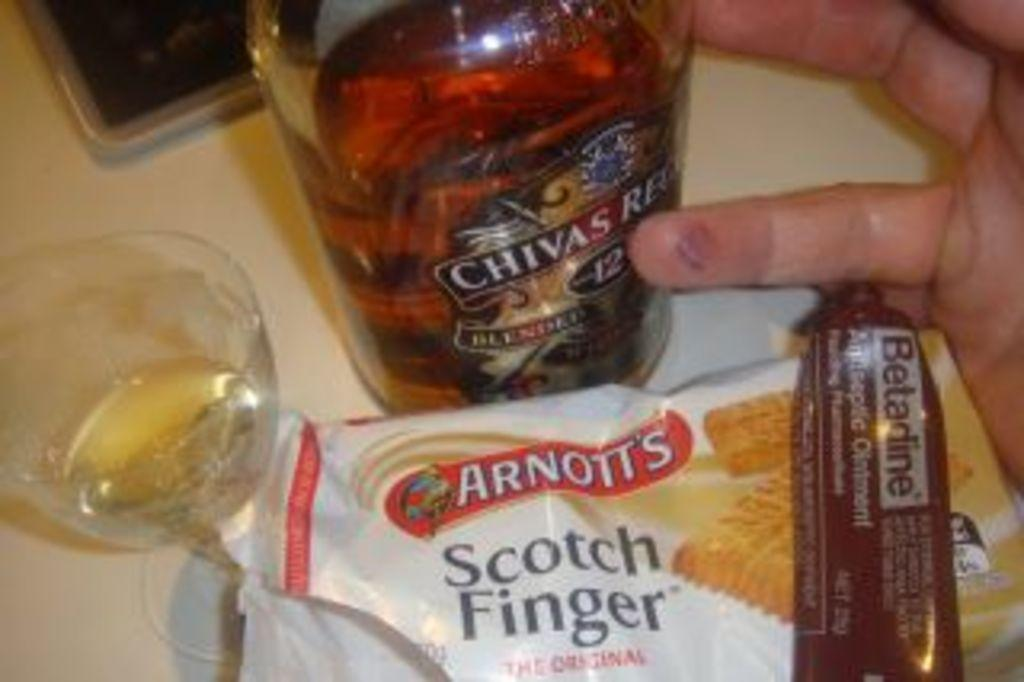<image>
Offer a succinct explanation of the picture presented. a person's hand displaying Arnott's Scotch Finger and Chivas Regal 